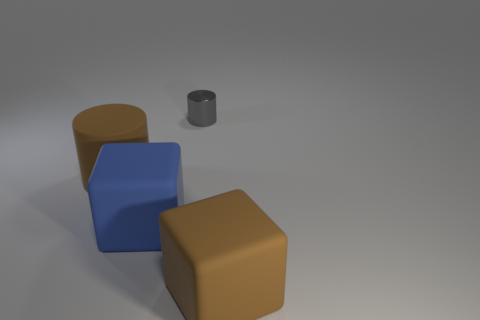Add 4 tiny gray metal cylinders. How many objects exist? 8 Subtract 0 cyan blocks. How many objects are left? 4 Subtract all green balls. Subtract all large brown things. How many objects are left? 2 Add 4 large brown rubber cylinders. How many large brown rubber cylinders are left? 5 Add 2 blue cylinders. How many blue cylinders exist? 2 